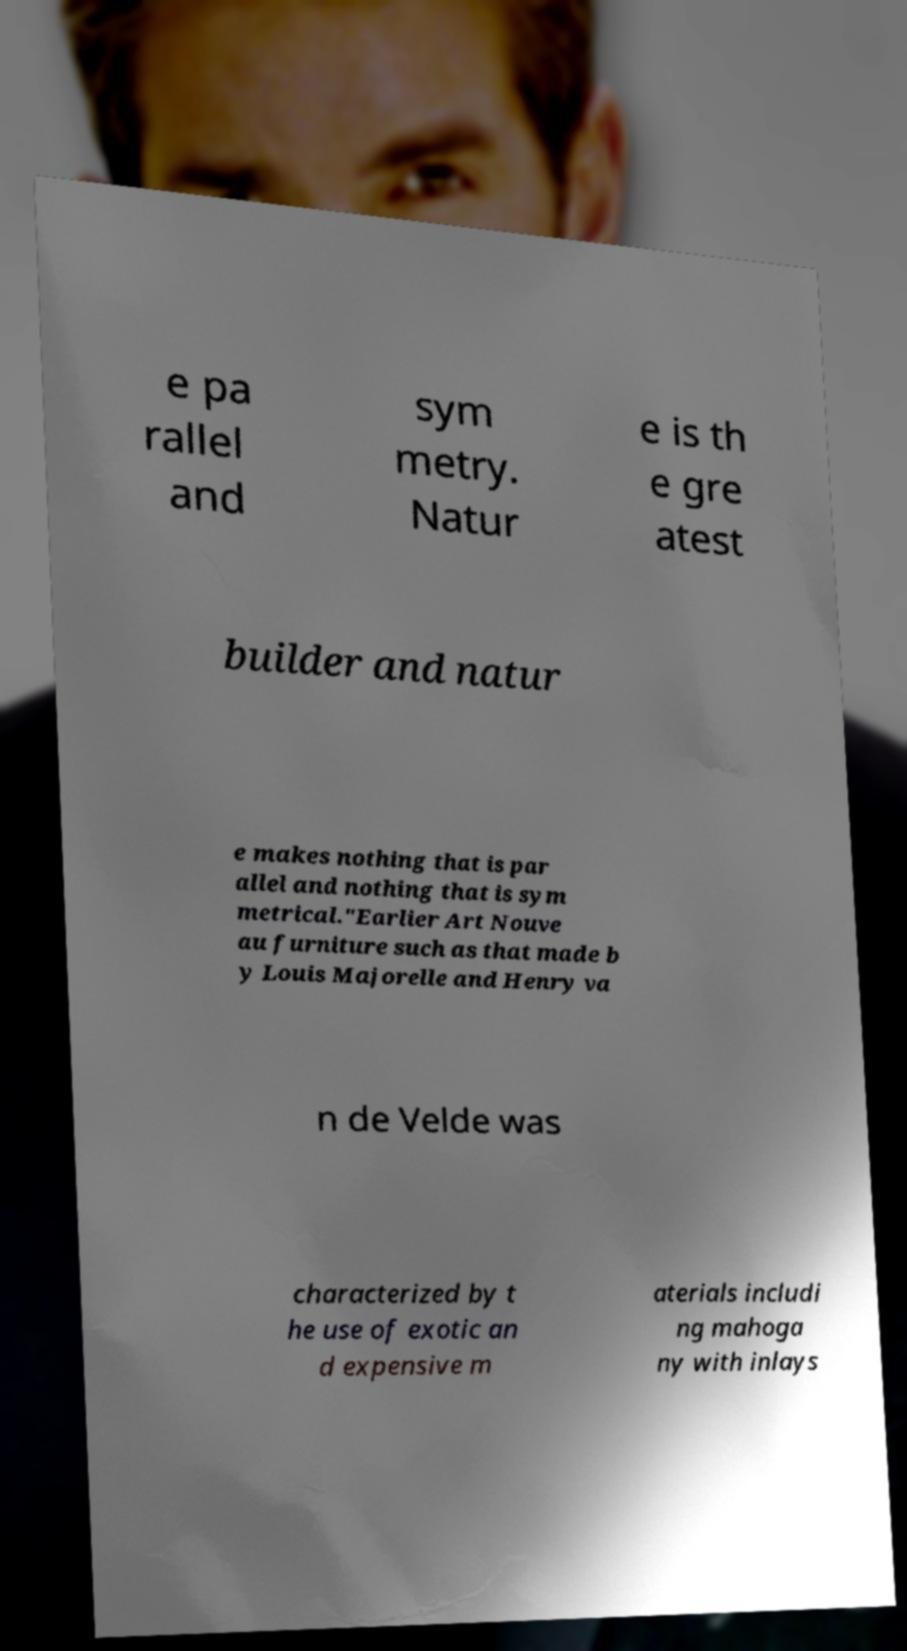Could you extract and type out the text from this image? e pa rallel and sym metry. Natur e is th e gre atest builder and natur e makes nothing that is par allel and nothing that is sym metrical."Earlier Art Nouve au furniture such as that made b y Louis Majorelle and Henry va n de Velde was characterized by t he use of exotic an d expensive m aterials includi ng mahoga ny with inlays 